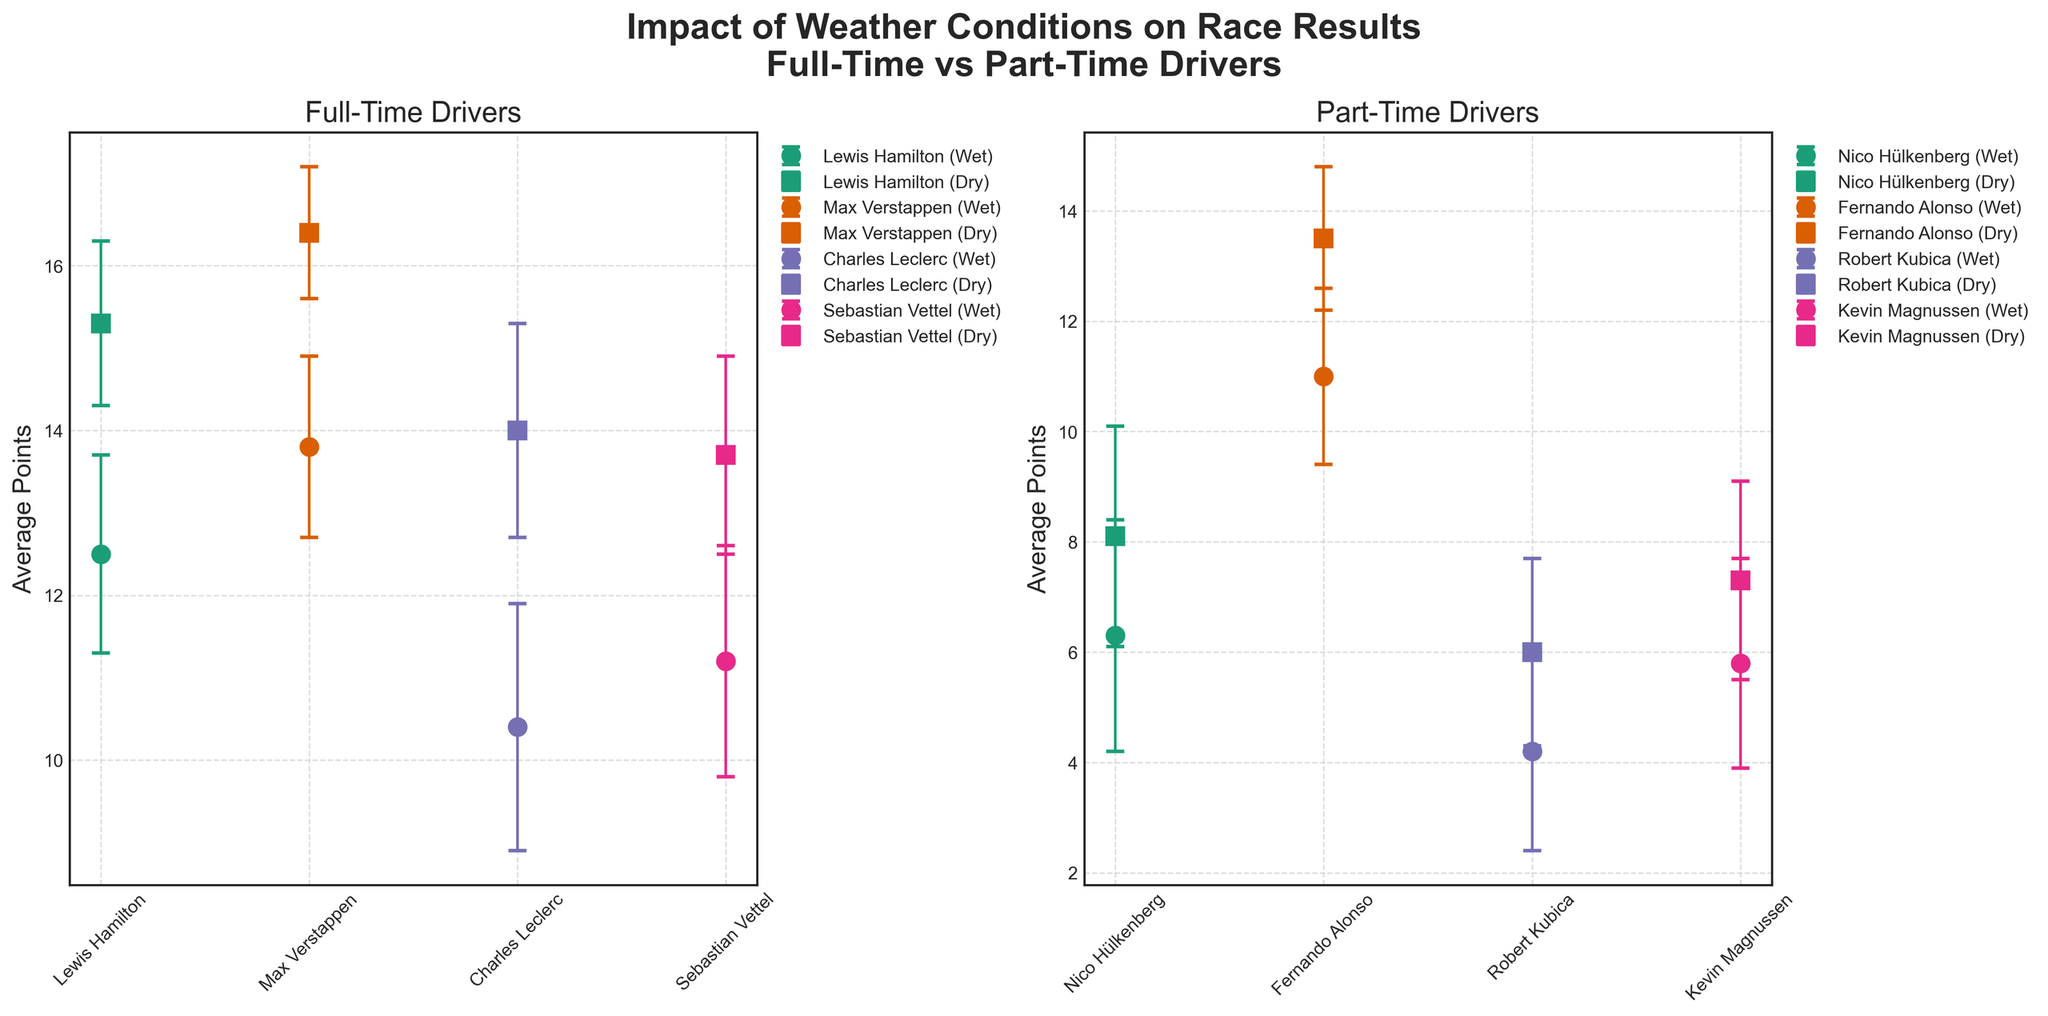Who scored the highest average points in dry conditions among full-time drivers? According to the plot, in dry conditions, Max Verstappen scored the highest average points among full-time drivers. This can be determined by comparing the average points values shown in the plot for Lewis Hamilton, Max Verstappen, Charles Leclerc, and Sebastian Vettel in dry conditions.
Answer: Max Verstappen Which part-time driver has the largest error bar in wet conditions? The error bars represent the standard deviation. Among part-time drivers in wet conditions, Nico Hülkenberg has the largest error bar, indicating the highest variability in his average points.
Answer: Nico Hülkenberg What is the difference in average points between wet and dry conditions for Lewis Hamilton? According to the plot, Lewis Hamilton's average points in wet conditions are 12.5 and in dry conditions are 15.3. The difference between these values can be calculated as 15.3 - 12.5.
Answer: 2.8 Did any part-time driver have lower average points in dry conditions compared to another driver’s wet conditions among the full-time drivers? Comparing the values, all part-time drivers have lower average points in dry conditions than Max Verstappen and Lewis Hamilton in wet conditions. Max Verstappen scored 13.8 points and Lewis Hamilton scored 12.5 points in wet conditions, which are all higher than the average points of part-time drivers in dry conditions.
Answer: Yes Is there any full-time driver whose performance in wet conditions is better than any other driver’s performance in dry conditions among the part-time drivers? Comparing the average points, Max Verstappen's performance in wet conditions (13.8 points) is higher than all part-time drivers' performance in dry conditions.
Answer: Yes Which driver shows the least variability in performance in dry conditions? The standard deviation (error bars) in dry conditions are compared, and Max Verstappen shows the least variability with the smallest error bar (Standard Deviation = 0.8).
Answer: Max Verstappen How do the average points in wet conditions compare for Charles Leclerc and Sebastian Vettel? In wet conditions, Charles Leclerc scored 10.4 average points, while Sebastian Vettel scored 11.2 average points. Therefore, Sebastian Vettel scored slightly more points than Charles Leclerc in wet conditions.
Answer: Sebastian Vettel Are there any drivers, full-time or part-time, that consistently score more average points in dry conditions compared to wet conditions? The plot shows that all drivers have higher average points in dry conditions compared to wet conditions. This is true for both full-time drivers like Lewis Hamilton and part-time drivers like Nico Hülkenberg.
Answer: Yes Which part-time driver has the highest average points in dry conditions? According to the plot, Fernando Alonso has the highest average points among part-time drivers in dry conditions, scoring 13.5 points.
Answer: Fernando Alonso 